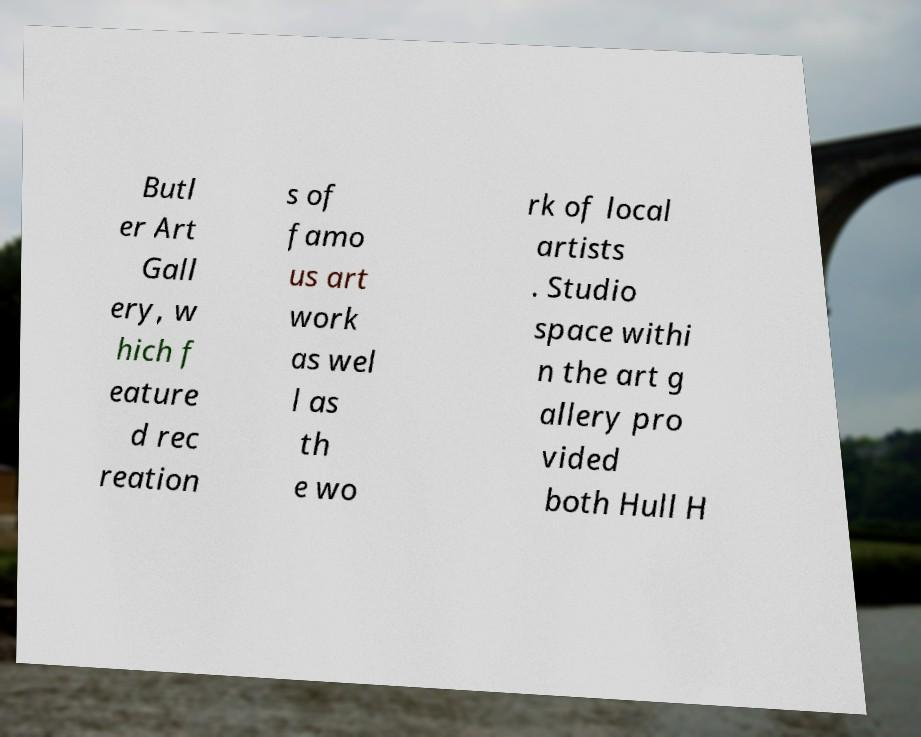Could you extract and type out the text from this image? Butl er Art Gall ery, w hich f eature d rec reation s of famo us art work as wel l as th e wo rk of local artists . Studio space withi n the art g allery pro vided both Hull H 